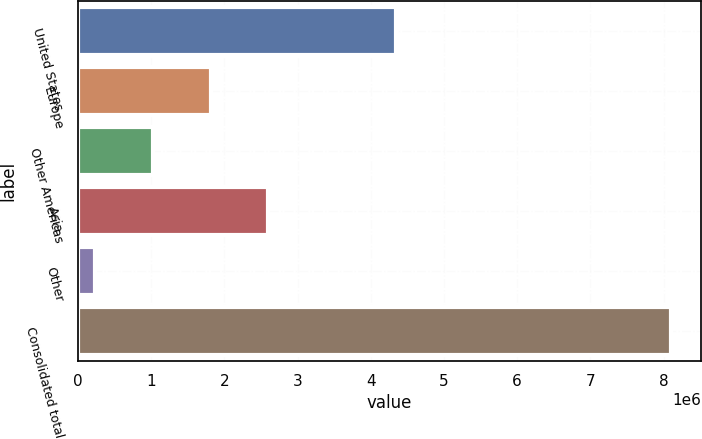Convert chart to OTSL. <chart><loc_0><loc_0><loc_500><loc_500><bar_chart><fcel>United States<fcel>Europe<fcel>Other Americas<fcel>Asia<fcel>Other<fcel>Consolidated total<nl><fcel>4.34395e+06<fcel>1.81156e+06<fcel>1.02496e+06<fcel>2.59816e+06<fcel>238364<fcel>8.10434e+06<nl></chart> 